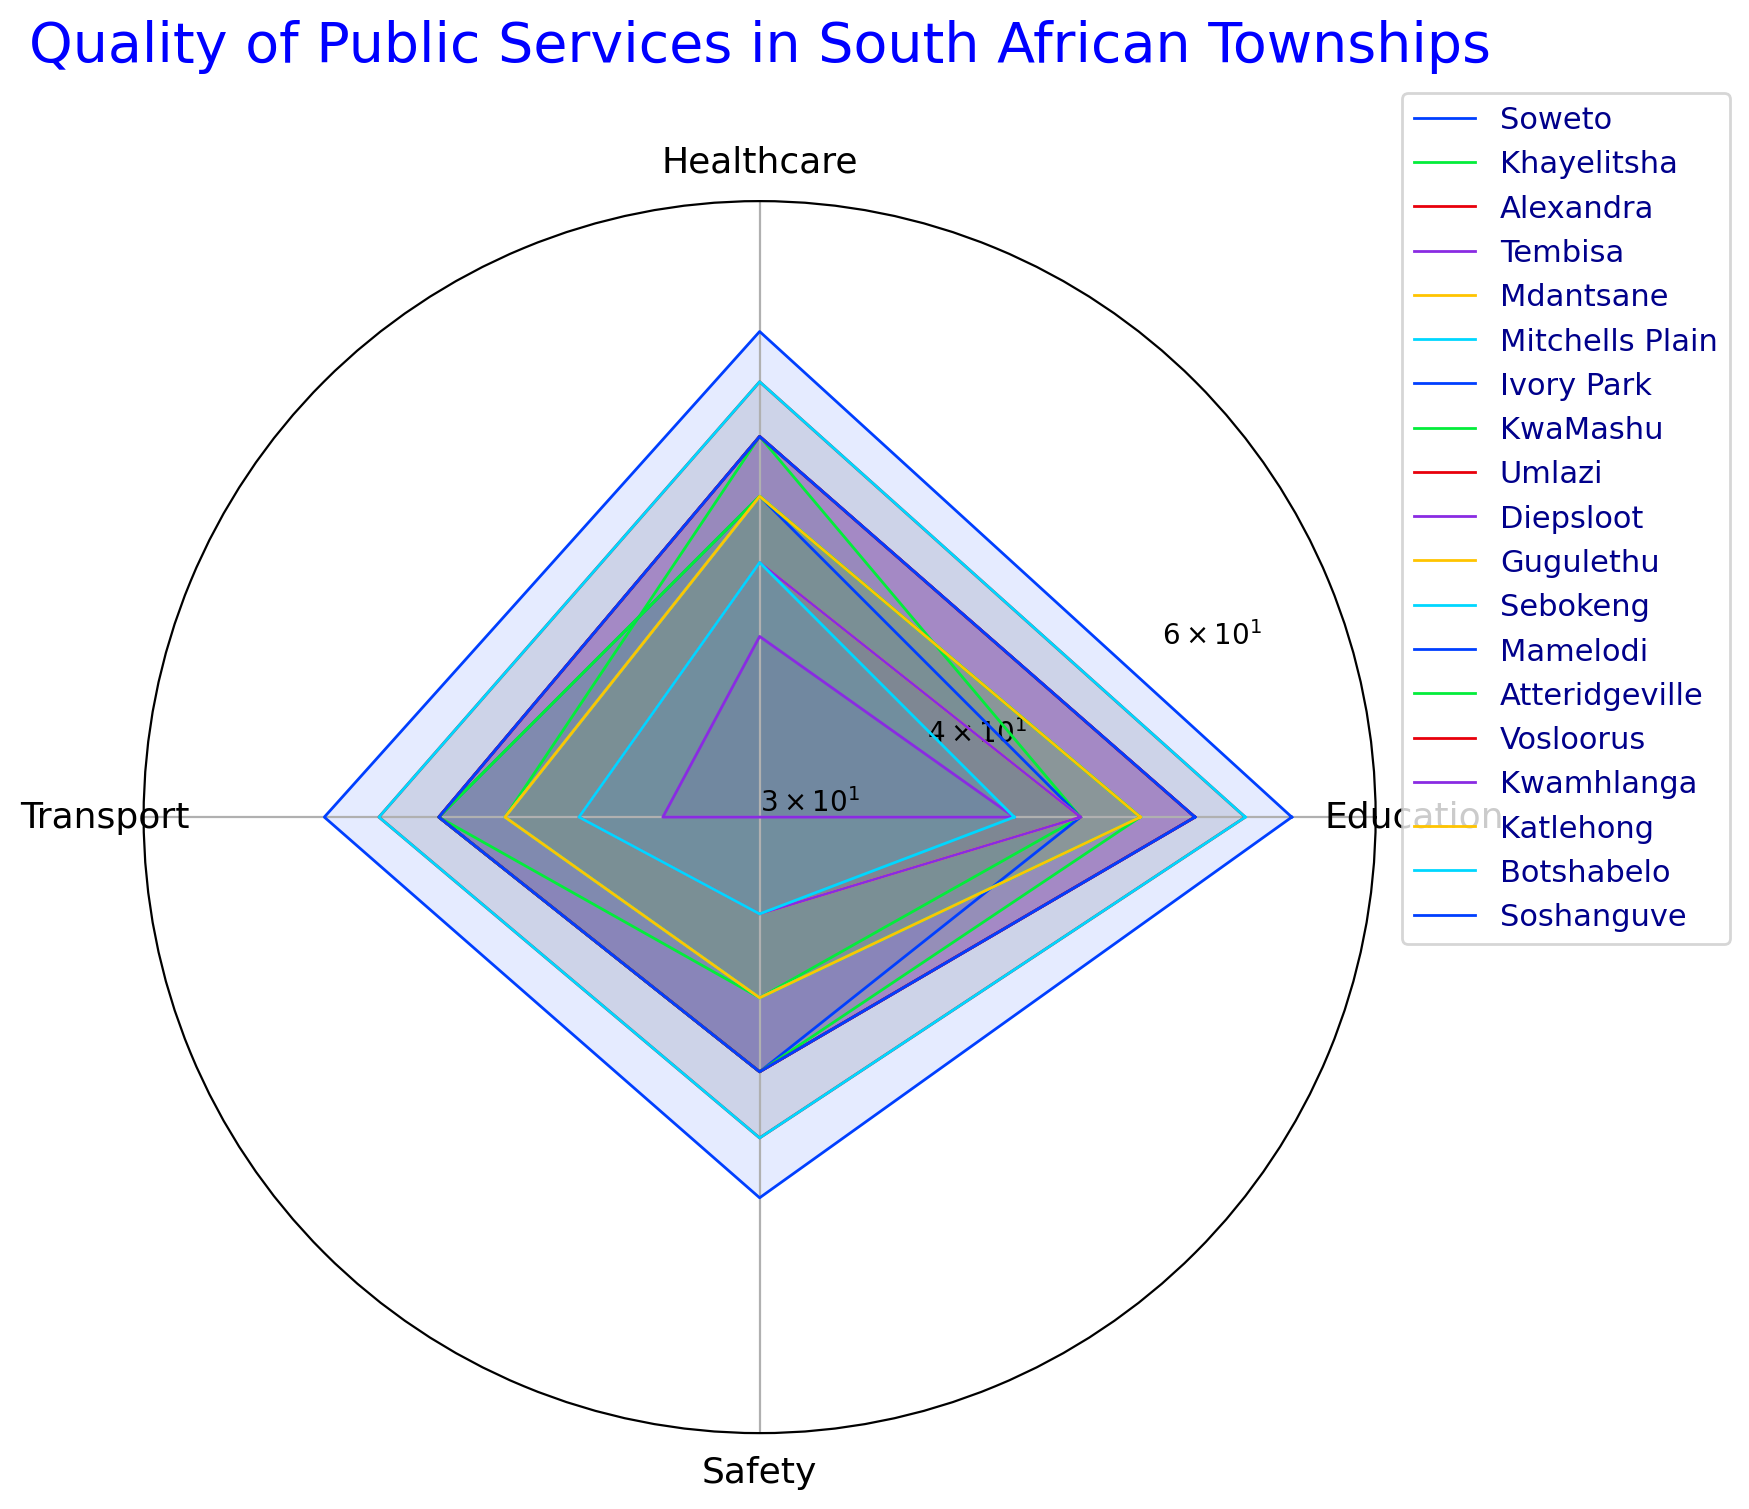Which township has the worst Safety rating? To determine the township with the worst Safety rating, we look at the data points for Safety in the radar chart. The Safety values range from 30 to 55, with Diepsloot showing the lowest Safety rating at 30.
Answer: Diepsloot Which township has the highest average rating across all categories? To find this, we need to calculate the average rating for Education, Healthcare, Transport, and Safety for each township and compare them. Soweto has high scores in all categories (70 + 65 + 60 + 55 = 250, average: 62.5), which appears to be the highest among all townships.
Answer: Soweto Which township has an Education rating equal to its Healthcare rating? By examining the values in the radar chart, we see that Ivory Park and Botshabelo have equal ratings for Education and Healthcare, both being 50 and 45 respectively.
Answer: Ivory Park, Botshabelo Does the township with the highest Transport rating also have the highest Healthcare rating? We check the township with the highest Transport rating (Soweto with a rating of 60) and compare its Healthcare rating (65). No other township has a higher Healthcare rating than Soweto.
Answer: Yes Compare Safety ratings between Alexandra and KwaMashu. Which one is higher? By comparing the Safety ratings on the radar chart, Alexandra has a Safety rating of 50, while KwaMashu has a rating of 40. Therefore, Alexandra's Safety rating is higher.
Answer: Alexandra What's the difference between the highest and lowest Education ratings among townships? The highest Education rating is from Soweto (70) and the lowest is from Diepsloot (45). The difference between these values is 70 - 45 = 25.
Answer: 25 Which township has the most balanced ratings across all categories? For each township, we observe the variation between the highest and lowest ratings in the radar chart. Townships like Soweto and Alexandra show relatively balanced ratings. Alexandra has less disparity (65, 60, 55, 50).
Answer: Alexandra If you average the Safety ratings of all townships, what value do you get? Sum up all Safety ratings from the data and divide by the number of townships (55 + 40 + 50 + 45 + 40 + 50 + 45 + 40 + 45 + 30 + 35 + 40 + 45 + 45 + 45 + 35 + 40 + 35 + 45 = 820). There are 19 townships, so the average is 820 / 19 ≈ 43.16.
Answer: 43.16 Is Education rating in Tembisa higher than the Healthcare rating in Mdantsane? Tembisa's Education rating is 60, while Mdantsane's Healthcare rating is 50. Since 60 > 50, Tembisa's Education rating is higher.
Answer: Yes Which township has the consistent lowest rating in all categories? By examining the radar chart, Diepsloot consistently has the lowest ratings in all categories (45, 40, 35, 30), compared to other townships.
Answer: Diepsloot 